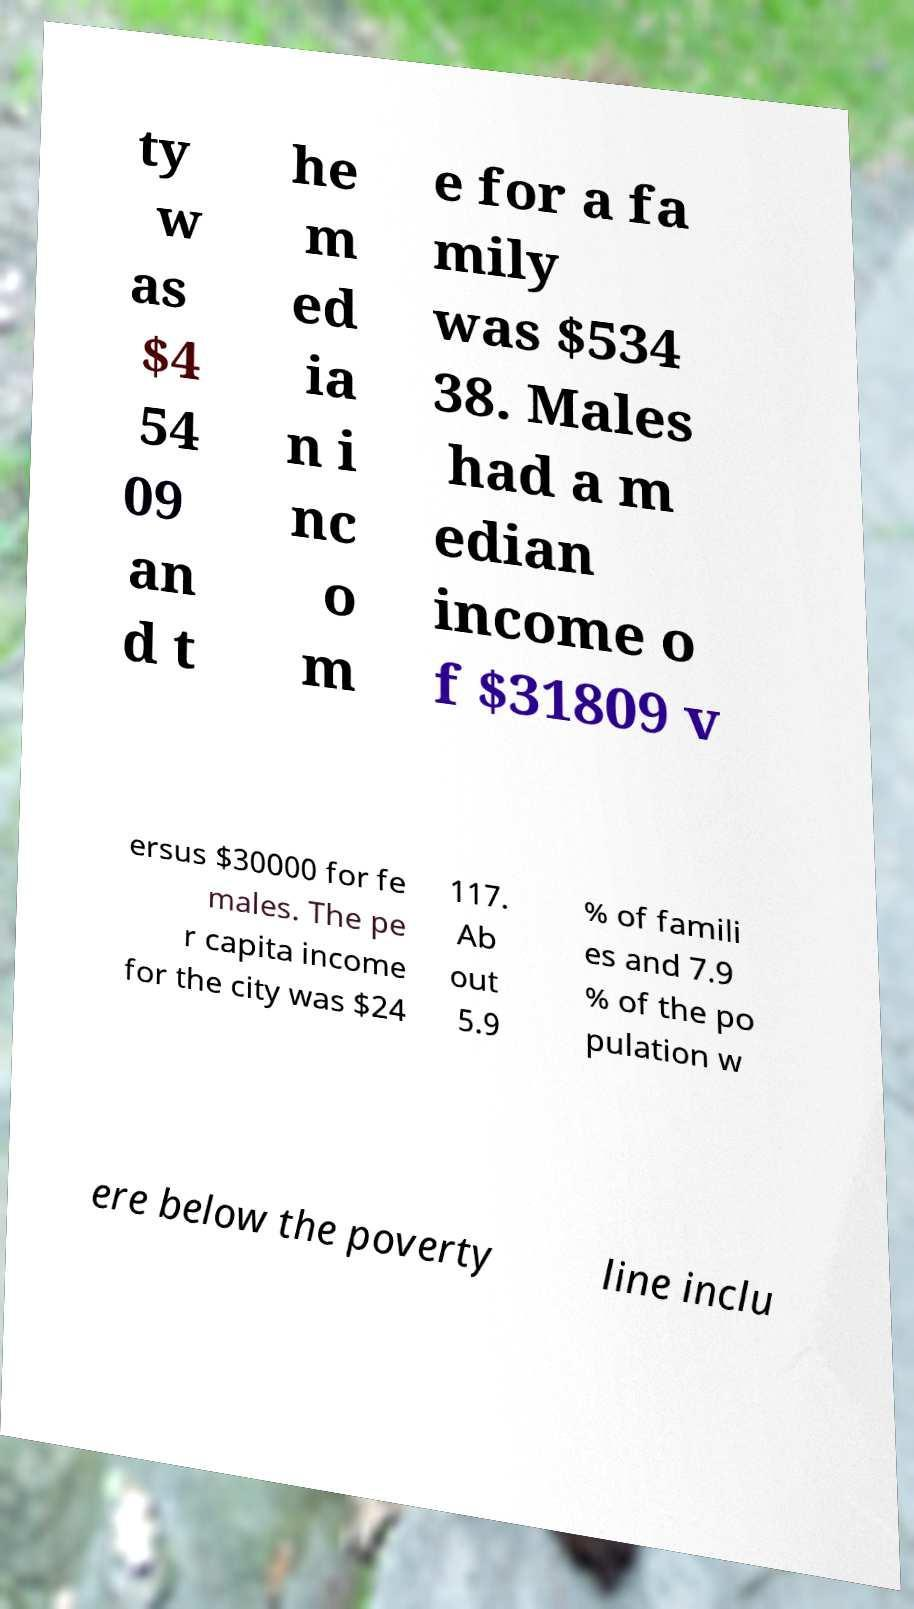Can you read and provide the text displayed in the image?This photo seems to have some interesting text. Can you extract and type it out for me? ty w as $4 54 09 an d t he m ed ia n i nc o m e for a fa mily was $534 38. Males had a m edian income o f $31809 v ersus $30000 for fe males. The pe r capita income for the city was $24 117. Ab out 5.9 % of famili es and 7.9 % of the po pulation w ere below the poverty line inclu 